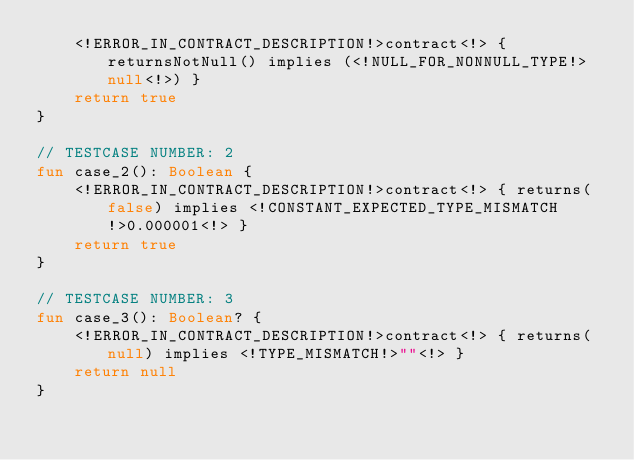Convert code to text. <code><loc_0><loc_0><loc_500><loc_500><_Kotlin_>    <!ERROR_IN_CONTRACT_DESCRIPTION!>contract<!> { returnsNotNull() implies (<!NULL_FOR_NONNULL_TYPE!>null<!>) }
    return true
}

// TESTCASE NUMBER: 2
fun case_2(): Boolean {
    <!ERROR_IN_CONTRACT_DESCRIPTION!>contract<!> { returns(false) implies <!CONSTANT_EXPECTED_TYPE_MISMATCH!>0.000001<!> }
    return true
}

// TESTCASE NUMBER: 3
fun case_3(): Boolean? {
    <!ERROR_IN_CONTRACT_DESCRIPTION!>contract<!> { returns(null) implies <!TYPE_MISMATCH!>""<!> }
    return null
}
</code> 